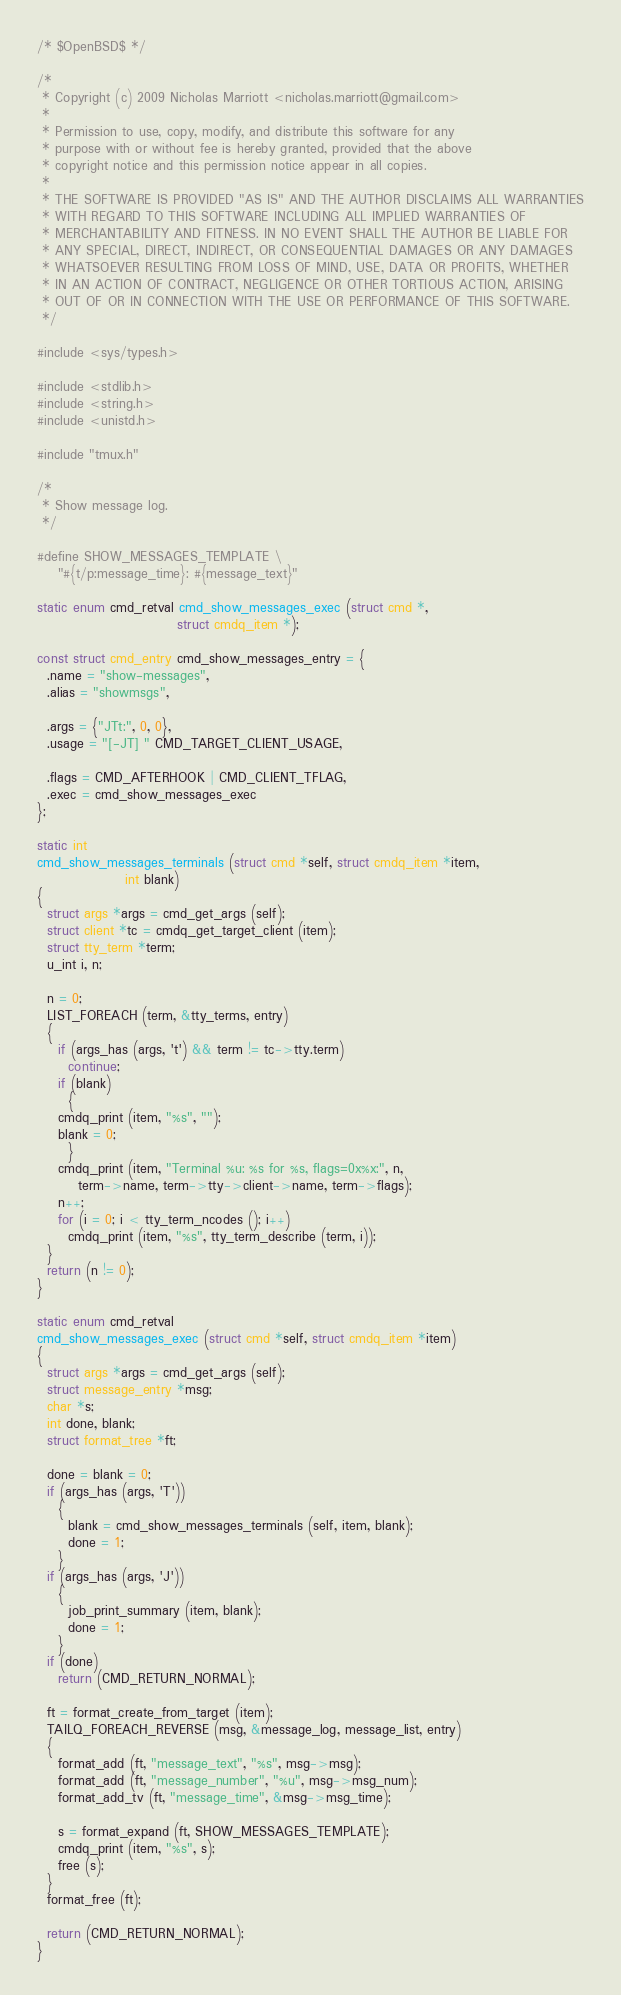Convert code to text. <code><loc_0><loc_0><loc_500><loc_500><_C_>/* $OpenBSD$ */

/*
 * Copyright (c) 2009 Nicholas Marriott <nicholas.marriott@gmail.com>
 *
 * Permission to use, copy, modify, and distribute this software for any
 * purpose with or without fee is hereby granted, provided that the above
 * copyright notice and this permission notice appear in all copies.
 *
 * THE SOFTWARE IS PROVIDED "AS IS" AND THE AUTHOR DISCLAIMS ALL WARRANTIES
 * WITH REGARD TO THIS SOFTWARE INCLUDING ALL IMPLIED WARRANTIES OF
 * MERCHANTABILITY AND FITNESS. IN NO EVENT SHALL THE AUTHOR BE LIABLE FOR
 * ANY SPECIAL, DIRECT, INDIRECT, OR CONSEQUENTIAL DAMAGES OR ANY DAMAGES
 * WHATSOEVER RESULTING FROM LOSS OF MIND, USE, DATA OR PROFITS, WHETHER
 * IN AN ACTION OF CONTRACT, NEGLIGENCE OR OTHER TORTIOUS ACTION, ARISING
 * OUT OF OR IN CONNECTION WITH THE USE OR PERFORMANCE OF THIS SOFTWARE.
 */

#include <sys/types.h>

#include <stdlib.h>
#include <string.h>
#include <unistd.h>

#include "tmux.h"

/*
 * Show message log.
 */

#define SHOW_MESSAGES_TEMPLATE \
	"#{t/p:message_time}: #{message_text}"

static enum cmd_retval cmd_show_messages_exec (struct cmd *,
					       struct cmdq_item *);

const struct cmd_entry cmd_show_messages_entry = {
  .name = "show-messages",
  .alias = "showmsgs",

  .args = {"JTt:", 0, 0},
  .usage = "[-JT] " CMD_TARGET_CLIENT_USAGE,

  .flags = CMD_AFTERHOOK | CMD_CLIENT_TFLAG,
  .exec = cmd_show_messages_exec
};

static int
cmd_show_messages_terminals (struct cmd *self, struct cmdq_item *item,
			     int blank)
{
  struct args *args = cmd_get_args (self);
  struct client *tc = cmdq_get_target_client (item);
  struct tty_term *term;
  u_int i, n;

  n = 0;
  LIST_FOREACH (term, &tty_terms, entry)
  {
    if (args_has (args, 't') && term != tc->tty.term)
      continue;
    if (blank)
      {
	cmdq_print (item, "%s", "");
	blank = 0;
      }
    cmdq_print (item, "Terminal %u: %s for %s, flags=0x%x:", n,
		term->name, term->tty->client->name, term->flags);
    n++;
    for (i = 0; i < tty_term_ncodes (); i++)
      cmdq_print (item, "%s", tty_term_describe (term, i));
  }
  return (n != 0);
}

static enum cmd_retval
cmd_show_messages_exec (struct cmd *self, struct cmdq_item *item)
{
  struct args *args = cmd_get_args (self);
  struct message_entry *msg;
  char *s;
  int done, blank;
  struct format_tree *ft;

  done = blank = 0;
  if (args_has (args, 'T'))
    {
      blank = cmd_show_messages_terminals (self, item, blank);
      done = 1;
    }
  if (args_has (args, 'J'))
    {
      job_print_summary (item, blank);
      done = 1;
    }
  if (done)
    return (CMD_RETURN_NORMAL);

  ft = format_create_from_target (item);
  TAILQ_FOREACH_REVERSE (msg, &message_log, message_list, entry)
  {
    format_add (ft, "message_text", "%s", msg->msg);
    format_add (ft, "message_number", "%u", msg->msg_num);
    format_add_tv (ft, "message_time", &msg->msg_time);

    s = format_expand (ft, SHOW_MESSAGES_TEMPLATE);
    cmdq_print (item, "%s", s);
    free (s);
  }
  format_free (ft);

  return (CMD_RETURN_NORMAL);
}
</code> 